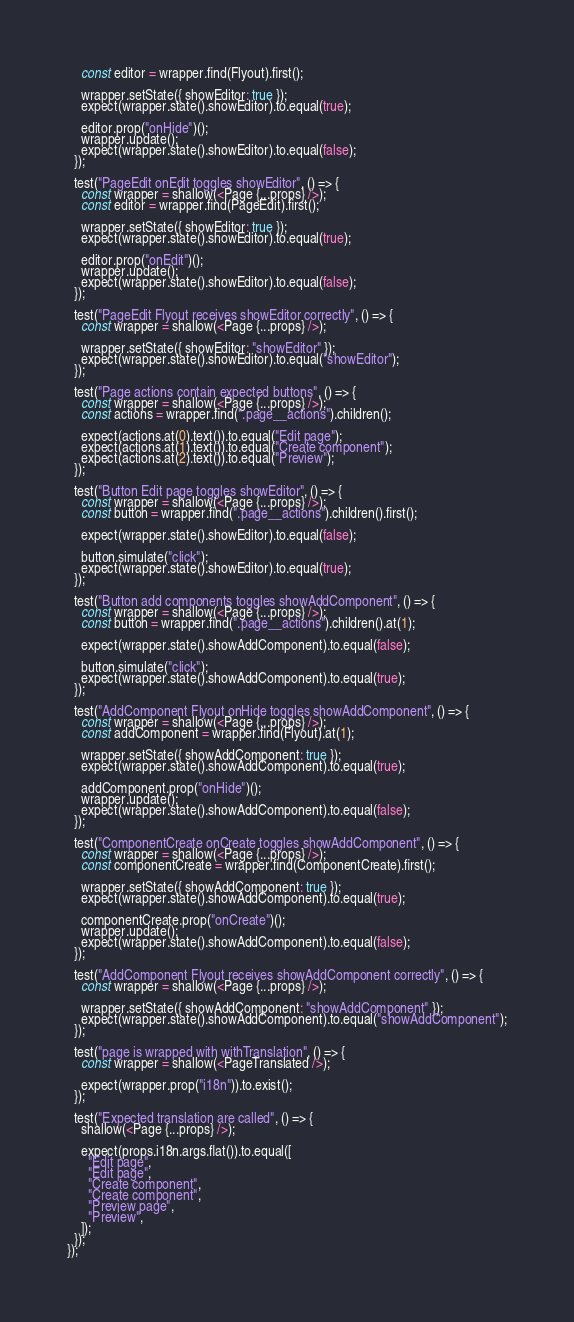Convert code to text. <code><loc_0><loc_0><loc_500><loc_500><_TypeScript_>    const editor = wrapper.find(Flyout).first();

    wrapper.setState({ showEditor: true });
    expect(wrapper.state().showEditor).to.equal(true);

    editor.prop("onHide")();
    wrapper.update();
    expect(wrapper.state().showEditor).to.equal(false);
  });

  test("PageEdit onEdit toggles showEditor", () => {
    const wrapper = shallow(<Page {...props} />);
    const editor = wrapper.find(PageEdit).first();

    wrapper.setState({ showEditor: true });
    expect(wrapper.state().showEditor).to.equal(true);

    editor.prop("onEdit")();
    wrapper.update();
    expect(wrapper.state().showEditor).to.equal(false);
  });

  test("PageEdit Flyout receives showEditor correctly", () => {
    const wrapper = shallow(<Page {...props} />);

    wrapper.setState({ showEditor: "showEditor" });
    expect(wrapper.state().showEditor).to.equal("showEditor");
  });

  test("Page actions contain expected buttons", () => {
    const wrapper = shallow(<Page {...props} />);
    const actions = wrapper.find(".page__actions").children();

    expect(actions.at(0).text()).to.equal("Edit page");
    expect(actions.at(1).text()).to.equal("Create component");
    expect(actions.at(2).text()).to.equal("Preview");
  });

  test("Button Edit page toggles showEditor", () => {
    const wrapper = shallow(<Page {...props} />);
    const button = wrapper.find(".page__actions").children().first();

    expect(wrapper.state().showEditor).to.equal(false);

    button.simulate("click");
    expect(wrapper.state().showEditor).to.equal(true);
  });

  test("Button add components toggles showAddComponent", () => {
    const wrapper = shallow(<Page {...props} />);
    const button = wrapper.find(".page__actions").children().at(1);

    expect(wrapper.state().showAddComponent).to.equal(false);

    button.simulate("click");
    expect(wrapper.state().showAddComponent).to.equal(true);
  });

  test("AddComponent Flyout onHide toggles showAddComponent", () => {
    const wrapper = shallow(<Page {...props} />);
    const addComponent = wrapper.find(Flyout).at(1);

    wrapper.setState({ showAddComponent: true });
    expect(wrapper.state().showAddComponent).to.equal(true);

    addComponent.prop("onHide")();
    wrapper.update();
    expect(wrapper.state().showAddComponent).to.equal(false);
  });

  test("ComponentCreate onCreate toggles showAddComponent", () => {
    const wrapper = shallow(<Page {...props} />);
    const componentCreate = wrapper.find(ComponentCreate).first();

    wrapper.setState({ showAddComponent: true });
    expect(wrapper.state().showAddComponent).to.equal(true);

    componentCreate.prop("onCreate")();
    wrapper.update();
    expect(wrapper.state().showAddComponent).to.equal(false);
  });

  test("AddComponent Flyout receives showAddComponent correctly", () => {
    const wrapper = shallow(<Page {...props} />);

    wrapper.setState({ showAddComponent: "showAddComponent" });
    expect(wrapper.state().showAddComponent).to.equal("showAddComponent");
  });

  test("page is wrapped with withTranslation", () => {
    const wrapper = shallow(<PageTranslated />);

    expect(wrapper.prop("i18n")).to.exist();
  });

  test("Expected translation are called", () => {
    shallow(<Page {...props} />);

    expect(props.i18n.args.flat()).to.equal([
      "Edit page",
      "Edit page",
      "Create component",
      "Create component",
      "Preview page",
      "Preview",
    ]);
  });
});
</code> 